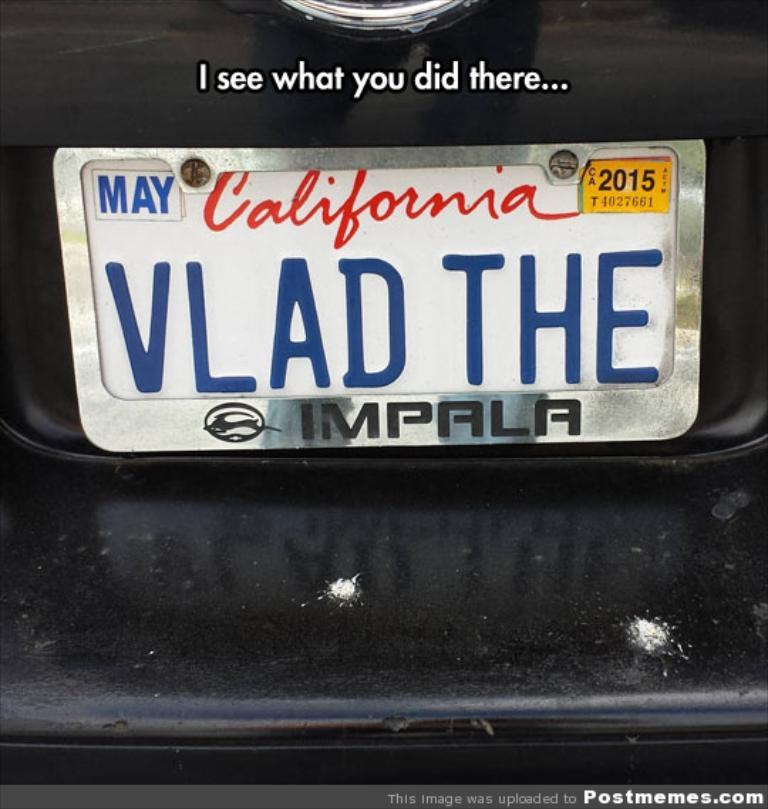Provide a one-sentence caption for the provided image. A meme image showing a license plate with a pun Vlad the Impala. 